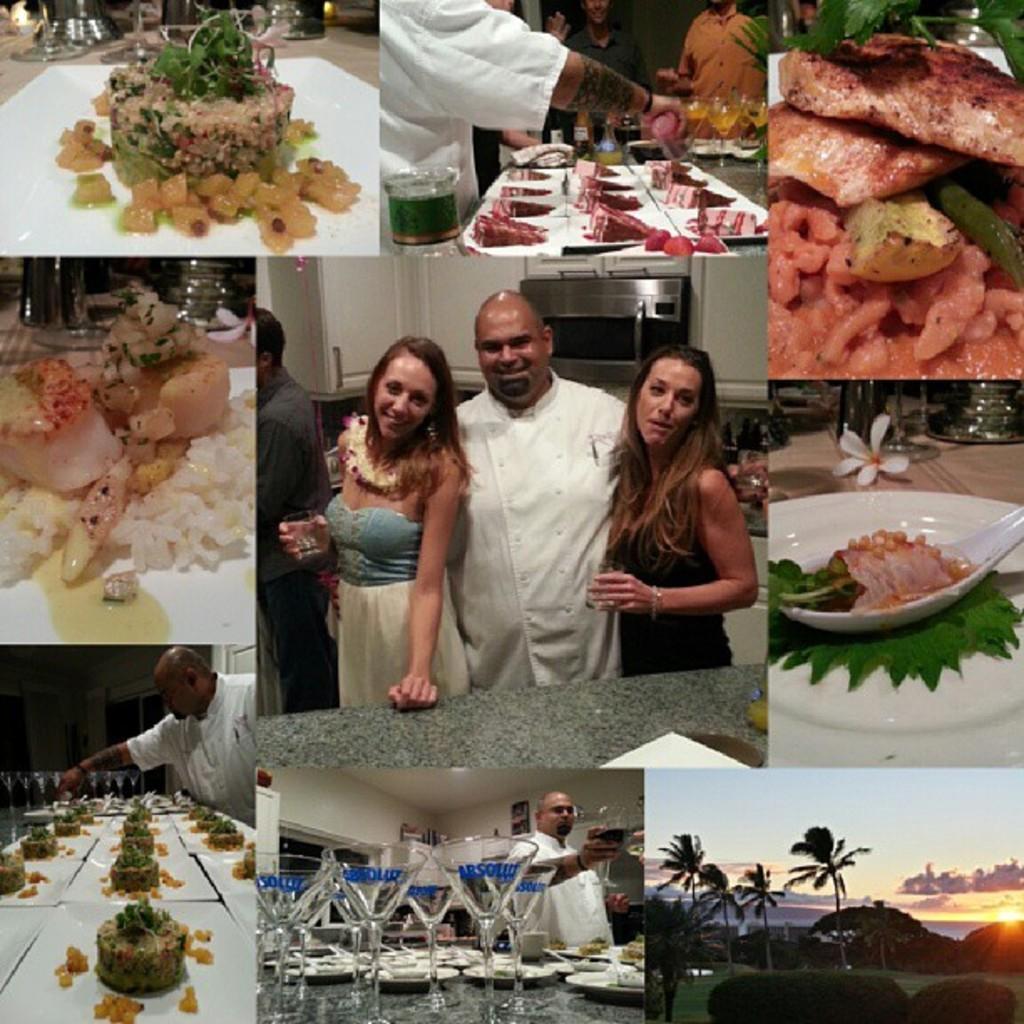Can you describe this image briefly? This is a collage image of different dishes of food items, in the center of the image there are three people posing for the camera with a smile on their face. 